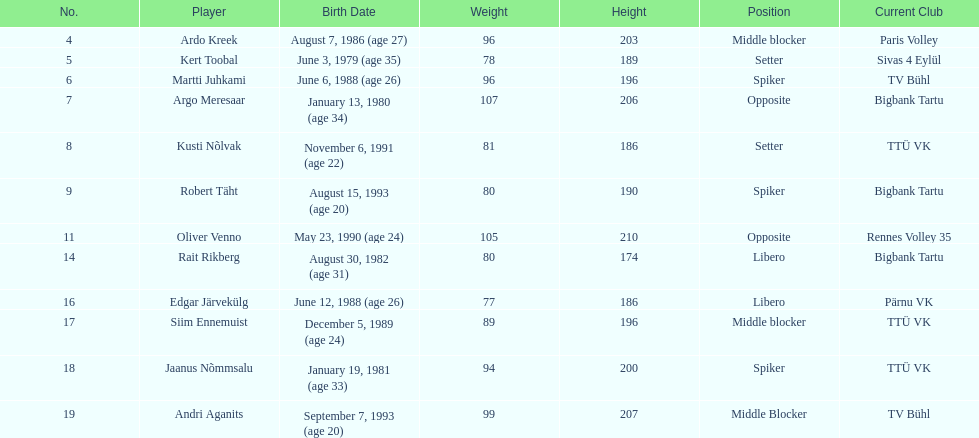Among the members of the estonian men's national volleyball team, how many have a birth year of 1988? 2. 